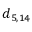Convert formula to latex. <formula><loc_0><loc_0><loc_500><loc_500>d _ { 5 , 1 4 }</formula> 